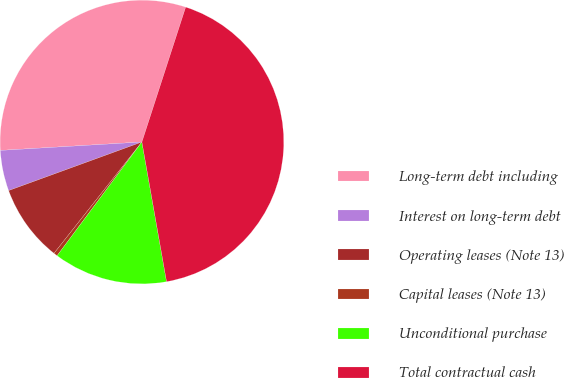Convert chart. <chart><loc_0><loc_0><loc_500><loc_500><pie_chart><fcel>Long-term debt including<fcel>Interest on long-term debt<fcel>Operating leases (Note 13)<fcel>Capital leases (Note 13)<fcel>Unconditional purchase<fcel>Total contractual cash<nl><fcel>30.94%<fcel>4.62%<fcel>8.8%<fcel>0.44%<fcel>12.98%<fcel>42.23%<nl></chart> 